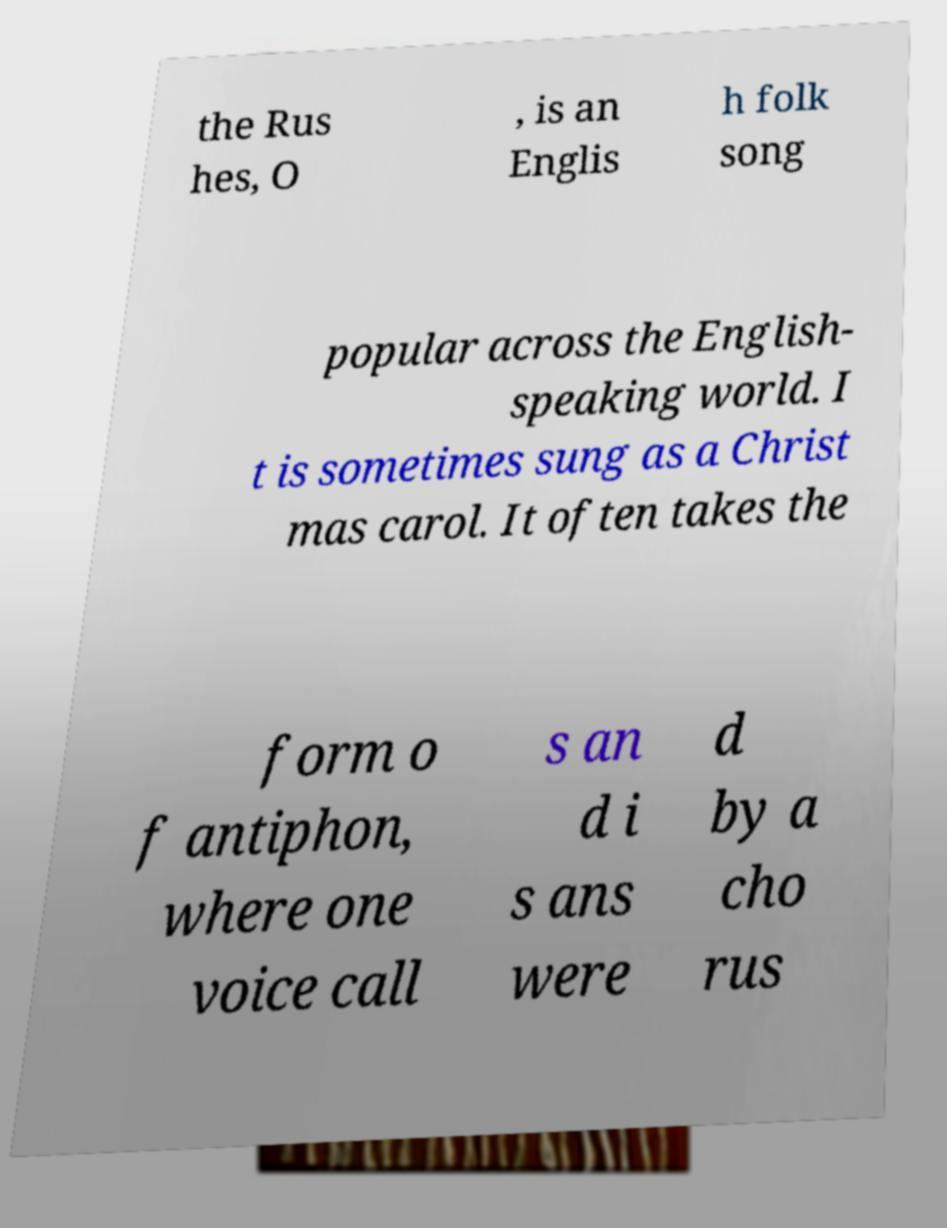Could you extract and type out the text from this image? the Rus hes, O , is an Englis h folk song popular across the English- speaking world. I t is sometimes sung as a Christ mas carol. It often takes the form o f antiphon, where one voice call s an d i s ans were d by a cho rus 